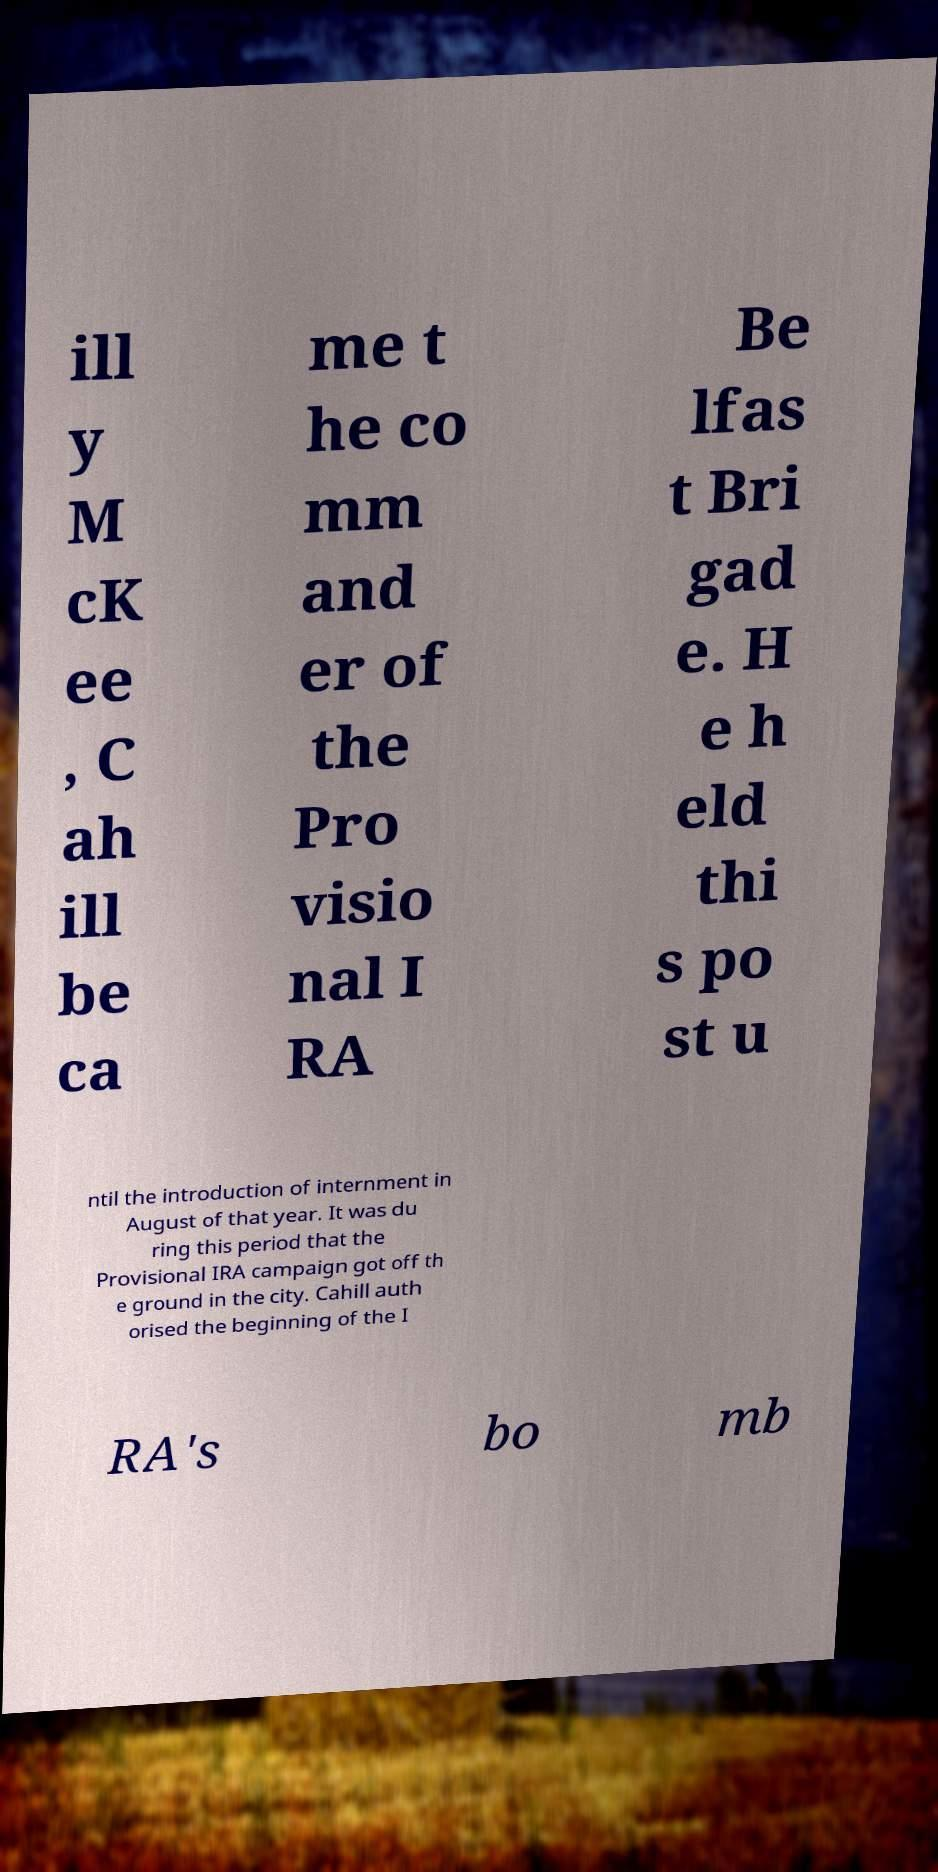I need the written content from this picture converted into text. Can you do that? ill y M cK ee , C ah ill be ca me t he co mm and er of the Pro visio nal I RA Be lfas t Bri gad e. H e h eld thi s po st u ntil the introduction of internment in August of that year. It was du ring this period that the Provisional IRA campaign got off th e ground in the city. Cahill auth orised the beginning of the I RA's bo mb 